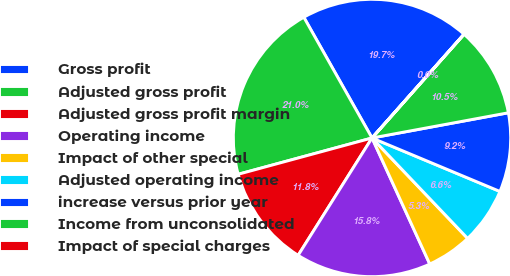<chart> <loc_0><loc_0><loc_500><loc_500><pie_chart><fcel>Gross profit<fcel>Adjusted gross profit<fcel>Adjusted gross profit margin<fcel>Operating income<fcel>Impact of other special<fcel>Adjusted operating income<fcel>increase versus prior year<fcel>Income from unconsolidated<fcel>Impact of special charges<nl><fcel>19.72%<fcel>21.03%<fcel>11.84%<fcel>15.78%<fcel>5.27%<fcel>6.59%<fcel>9.21%<fcel>10.53%<fcel>0.02%<nl></chart> 